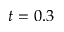<formula> <loc_0><loc_0><loc_500><loc_500>t = 0 . 3</formula> 